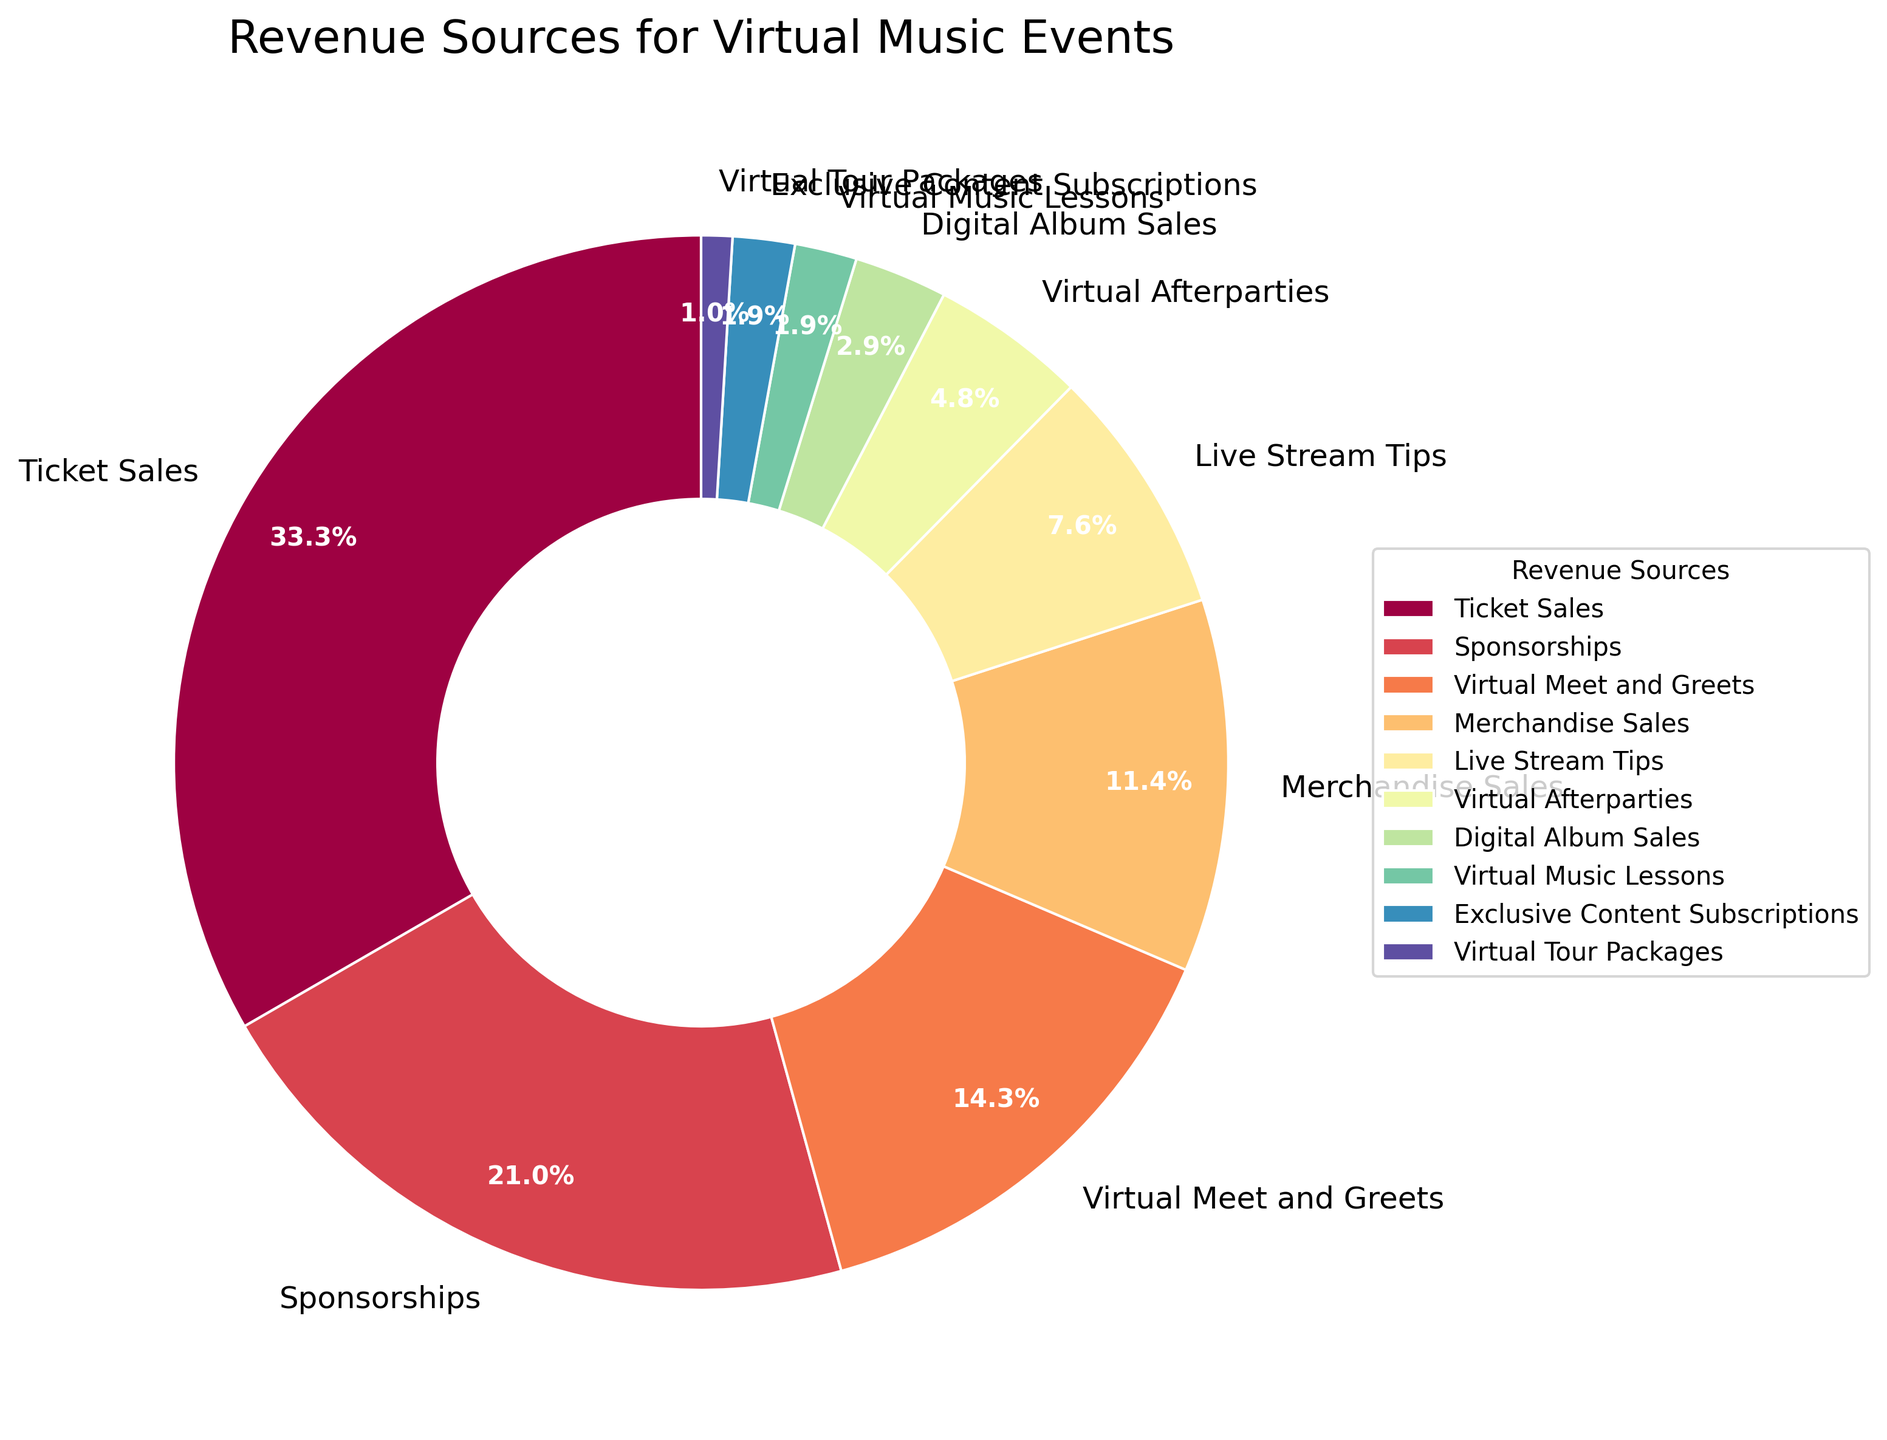what revenue source contributes the most to the total? The largest segment in the pie chart is labeled "Ticket Sales" with a percentage of 35%.
Answer: Ticket Sales How much more revenue does Ticket Sales generate compared to Merchandise Sales? Ticket Sales generate 35%, while Merchandise Sales generate 12%. Thus, the difference is 35% - 12% = 23%.
Answer: 23% Which revenue sources contribute exactly 2% each? By looking at the pie chart, "Virtual Music Lessons" and "Exclusive Content Subscriptions" both show a contribution of 2%.
Answer: Virtual Music Lessons and Exclusive Content Subscriptions What's the combined revenue percentage of Sponsorships and Live Stream Tips? Sponsorships contribute 22% and Live Stream Tips contribute 8%. Adding these figures together, 22% + 8% = 30%.
Answer: 30% Which revenue source is the smallest contributor and what is its percentage? The smallest segment in the pie chart is labeled "Virtual Tour Packages" with a percentage of 1%.
Answer: Virtual Tour Packages, 1% Compare and contrast the contributions of Virtual Meet and Greets and Virtual Afterparties. Virtual Meet and Greets contribute 15%, whereas Virtual Afterparties contribute 5%. The difference is 15% - 5% = 10%.
Answer: Virtual Meet and Greets contribute 10% more Is the percentage of revenue from Sponsorships higher than that from Virtual Afterparties? Yes, Sponsorships contribute 22% while Virtual Afterparties contribute 5%. Thus, 22% is higher than 5%.
Answer: Yes What percentage of revenue comes from non-ticket sales sources combined? Summing up all sources except Ticket Sales: 22% (Sponsorships) + 15% (Virtual Meet and Greets) + 12% (Merchandise Sales) + 8% (Live Stream Tips) + 5% (Virtual Afterparties) + 3% (Digital Album Sales) + 2% (Virtual Music Lessons) + 2% (Exclusive Content Subscriptions) + 1% (Virtual Tour Packages) = 70%.
Answer: 70% Which revenue source has a percentage closest to 10%? The closest percentage to 10% in the pie chart is "Merchandise Sales" with 12%.
Answer: Merchandise Sales 